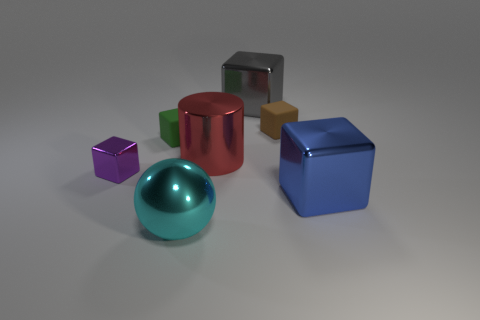What is the color of the shiny ball that is the same size as the cylinder?
Provide a succinct answer. Cyan. Is the number of small green blocks that are in front of the big red metal cylinder greater than the number of rubber objects?
Keep it short and to the point. No. There is a cube that is both in front of the big metal cylinder and behind the large blue shiny object; what is its material?
Make the answer very short. Metal. There is a big cube that is left of the blue thing; does it have the same color as the tiny block in front of the big metal cylinder?
Give a very brief answer. No. How many other things are the same size as the ball?
Provide a succinct answer. 3. Are there any big cyan metallic objects on the right side of the matte thing that is right of the red cylinder that is on the left side of the brown matte cube?
Provide a short and direct response. No. Do the large cube left of the large blue shiny block and the large red object have the same material?
Offer a terse response. Yes. What color is the other big thing that is the same shape as the blue thing?
Your answer should be compact. Gray. Is there anything else that has the same shape as the gray metallic thing?
Provide a succinct answer. Yes. Are there an equal number of tiny purple shiny things that are to the right of the red metallic thing and small rubber spheres?
Your response must be concise. Yes. 